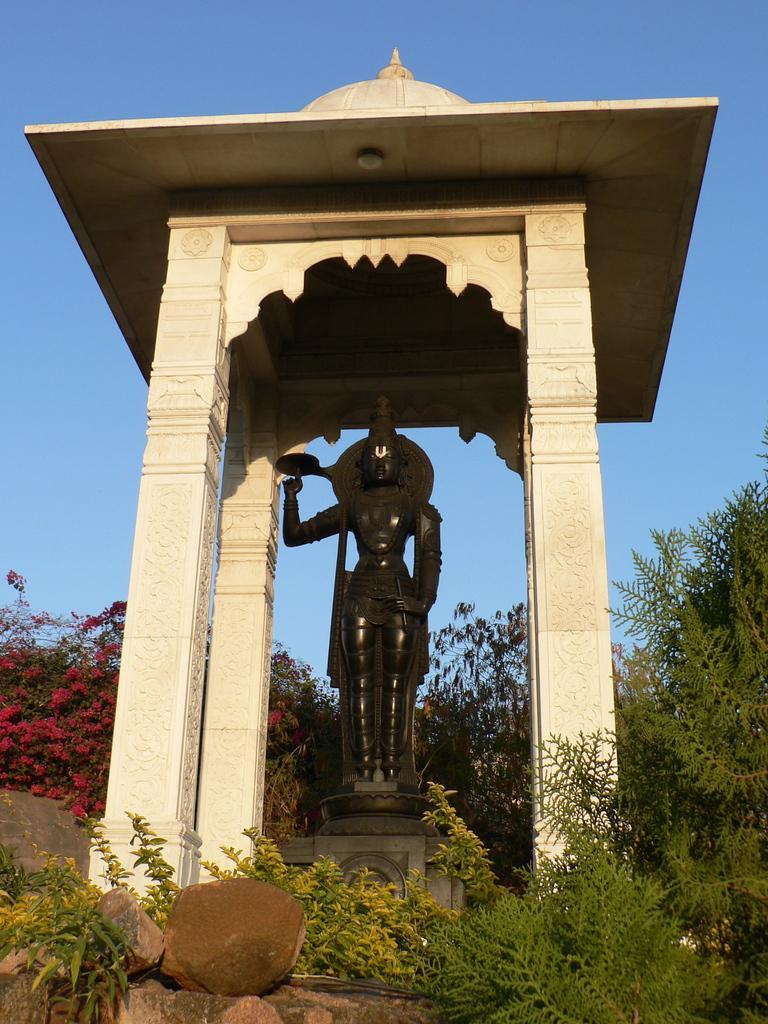Describe this image in one or two sentences. In this image, we can see a statue, pillars, plants, stones and trees. Background there is a sky. 